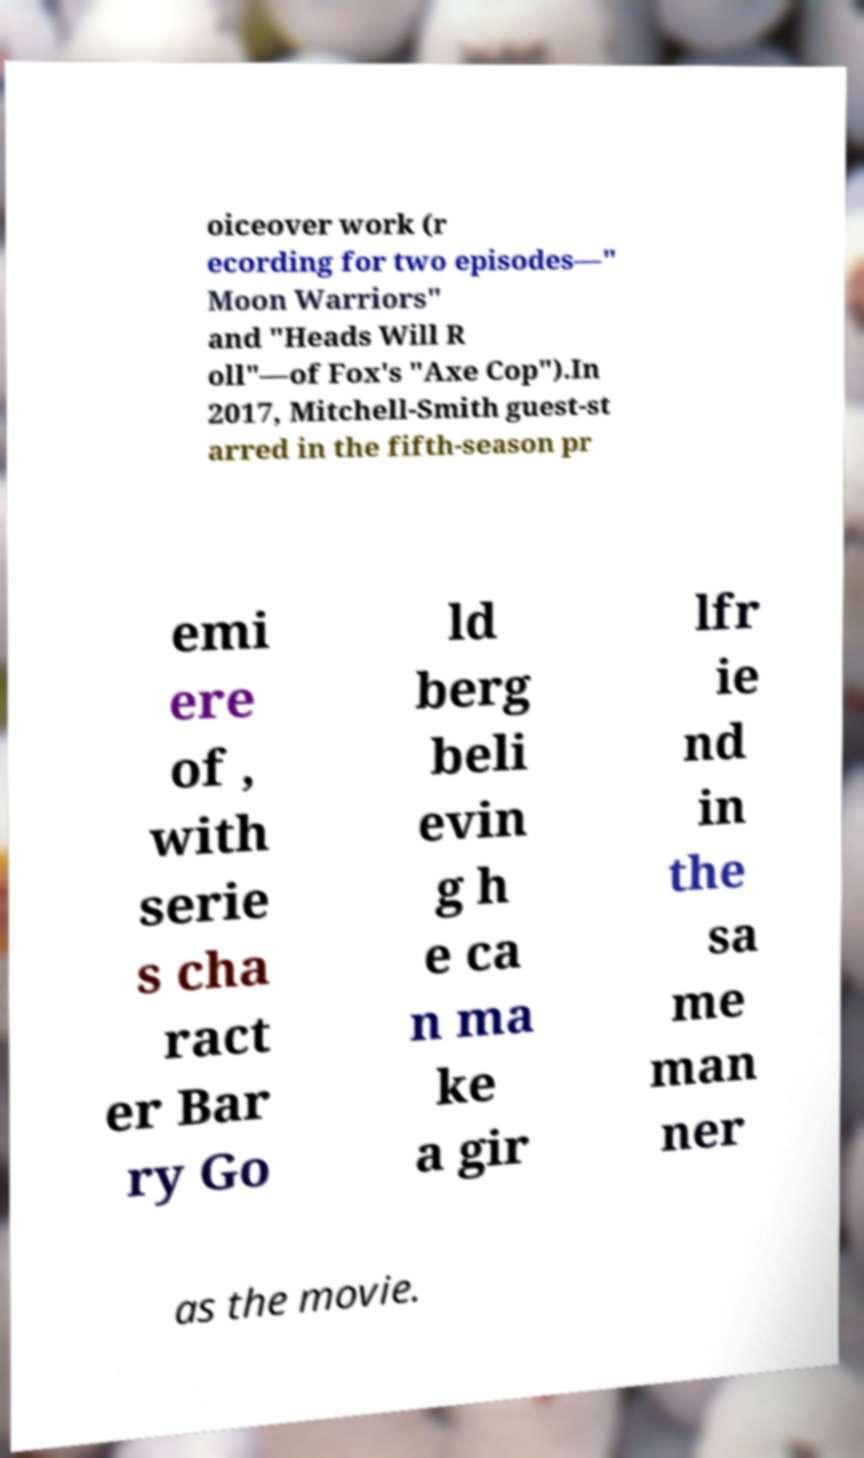There's text embedded in this image that I need extracted. Can you transcribe it verbatim? oiceover work (r ecording for two episodes—" Moon Warriors" and "Heads Will R oll"—of Fox's "Axe Cop").In 2017, Mitchell-Smith guest-st arred in the fifth-season pr emi ere of , with serie s cha ract er Bar ry Go ld berg beli evin g h e ca n ma ke a gir lfr ie nd in the sa me man ner as the movie. 